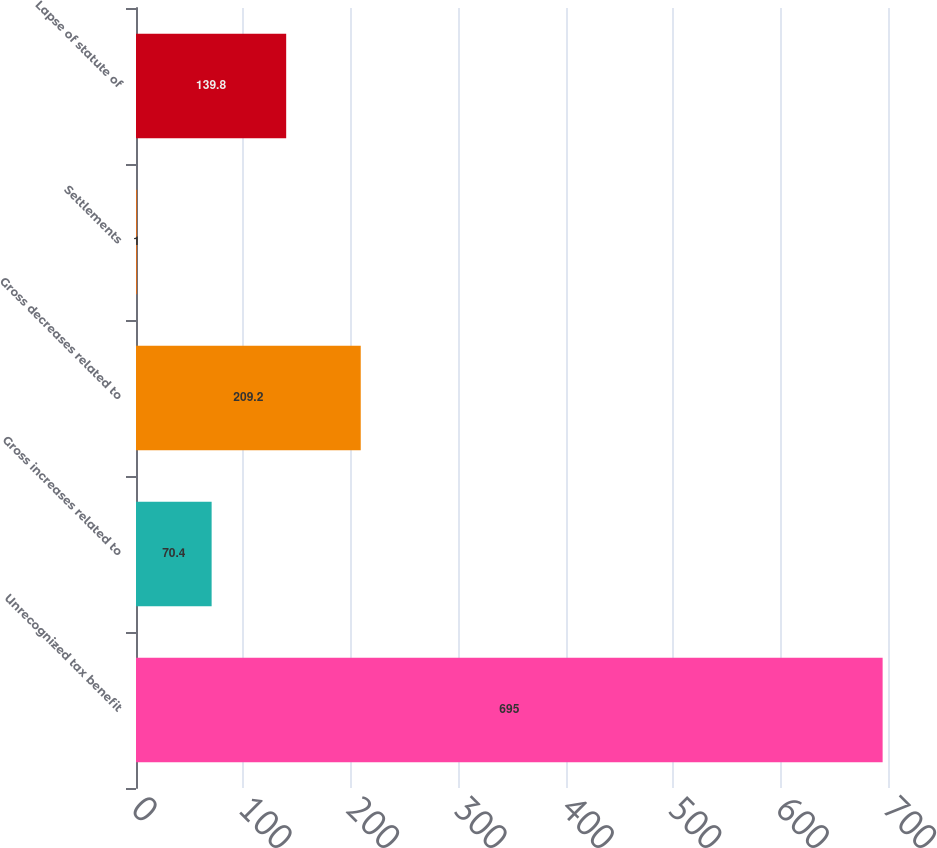Convert chart to OTSL. <chart><loc_0><loc_0><loc_500><loc_500><bar_chart><fcel>Unrecognized tax benefit<fcel>Gross increases related to<fcel>Gross decreases related to<fcel>Settlements<fcel>Lapse of statute of<nl><fcel>695<fcel>70.4<fcel>209.2<fcel>1<fcel>139.8<nl></chart> 